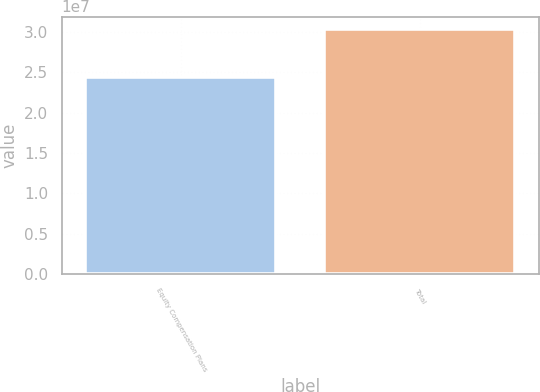Convert chart to OTSL. <chart><loc_0><loc_0><loc_500><loc_500><bar_chart><fcel>Equity Compensation Plans<fcel>Total<nl><fcel>2.44311e+07<fcel>3.03623e+07<nl></chart> 